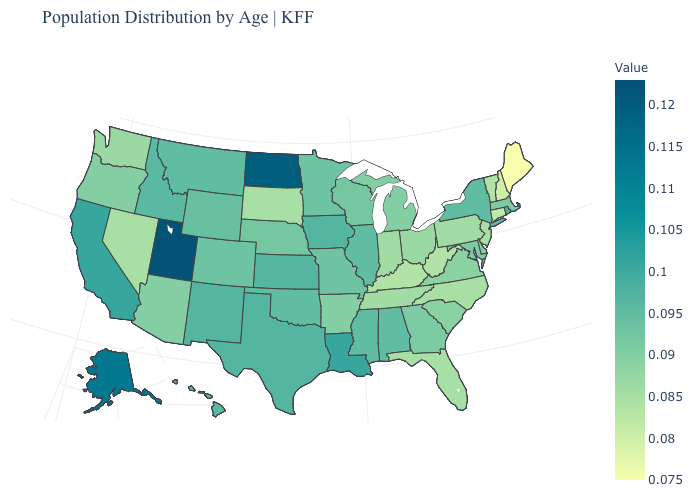Is the legend a continuous bar?
Short answer required. Yes. Is the legend a continuous bar?
Concise answer only. Yes. Does Utah have the highest value in the USA?
Write a very short answer. Yes. 